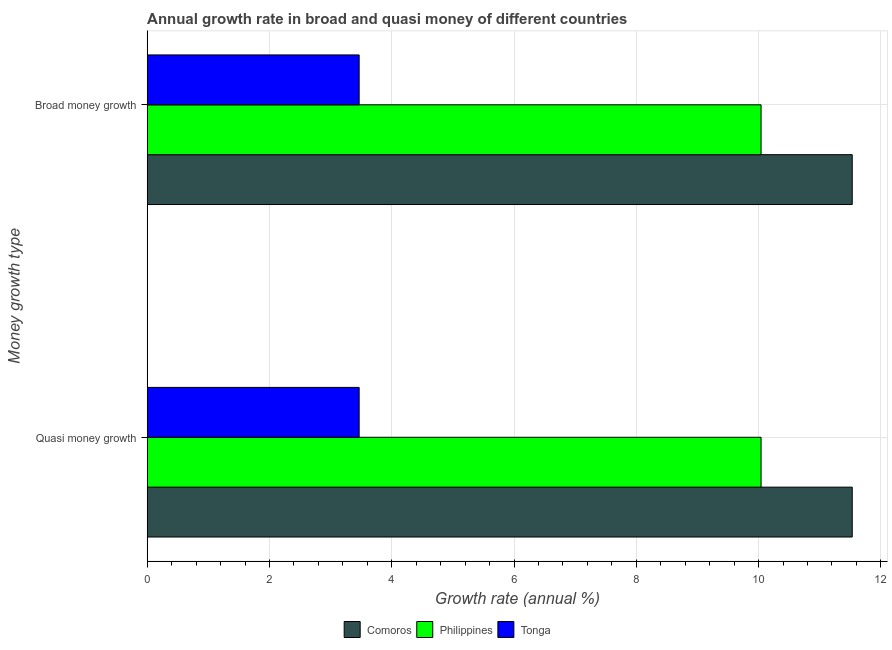How many different coloured bars are there?
Your answer should be compact. 3. Are the number of bars on each tick of the Y-axis equal?
Your response must be concise. Yes. How many bars are there on the 1st tick from the top?
Keep it short and to the point. 3. What is the label of the 2nd group of bars from the top?
Keep it short and to the point. Quasi money growth. What is the annual growth rate in broad money in Comoros?
Provide a short and direct response. 11.53. Across all countries, what is the maximum annual growth rate in broad money?
Your response must be concise. 11.53. Across all countries, what is the minimum annual growth rate in broad money?
Make the answer very short. 3.47. In which country was the annual growth rate in quasi money maximum?
Give a very brief answer. Comoros. In which country was the annual growth rate in quasi money minimum?
Your answer should be very brief. Tonga. What is the total annual growth rate in quasi money in the graph?
Offer a very short reply. 25.04. What is the difference between the annual growth rate in quasi money in Tonga and that in Comoros?
Your answer should be very brief. -8.06. What is the difference between the annual growth rate in broad money in Philippines and the annual growth rate in quasi money in Comoros?
Make the answer very short. -1.49. What is the average annual growth rate in quasi money per country?
Make the answer very short. 8.35. What is the ratio of the annual growth rate in broad money in Comoros to that in Tonga?
Your answer should be compact. 3.33. What does the 3rd bar from the top in Broad money growth represents?
Your response must be concise. Comoros. What does the 1st bar from the bottom in Quasi money growth represents?
Give a very brief answer. Comoros. Are all the bars in the graph horizontal?
Keep it short and to the point. Yes. How many countries are there in the graph?
Provide a short and direct response. 3. What is the difference between two consecutive major ticks on the X-axis?
Offer a very short reply. 2. Are the values on the major ticks of X-axis written in scientific E-notation?
Provide a short and direct response. No. Where does the legend appear in the graph?
Provide a short and direct response. Bottom center. How many legend labels are there?
Your answer should be compact. 3. How are the legend labels stacked?
Offer a very short reply. Horizontal. What is the title of the graph?
Offer a terse response. Annual growth rate in broad and quasi money of different countries. Does "St. Vincent and the Grenadines" appear as one of the legend labels in the graph?
Make the answer very short. No. What is the label or title of the X-axis?
Offer a terse response. Growth rate (annual %). What is the label or title of the Y-axis?
Provide a short and direct response. Money growth type. What is the Growth rate (annual %) of Comoros in Quasi money growth?
Provide a short and direct response. 11.53. What is the Growth rate (annual %) in Philippines in Quasi money growth?
Your answer should be compact. 10.04. What is the Growth rate (annual %) of Tonga in Quasi money growth?
Your response must be concise. 3.47. What is the Growth rate (annual %) of Comoros in Broad money growth?
Make the answer very short. 11.53. What is the Growth rate (annual %) in Philippines in Broad money growth?
Offer a terse response. 10.04. What is the Growth rate (annual %) of Tonga in Broad money growth?
Keep it short and to the point. 3.47. Across all Money growth type, what is the maximum Growth rate (annual %) of Comoros?
Offer a very short reply. 11.53. Across all Money growth type, what is the maximum Growth rate (annual %) of Philippines?
Offer a very short reply. 10.04. Across all Money growth type, what is the maximum Growth rate (annual %) of Tonga?
Keep it short and to the point. 3.47. Across all Money growth type, what is the minimum Growth rate (annual %) in Comoros?
Offer a terse response. 11.53. Across all Money growth type, what is the minimum Growth rate (annual %) in Philippines?
Offer a terse response. 10.04. Across all Money growth type, what is the minimum Growth rate (annual %) of Tonga?
Offer a very short reply. 3.47. What is the total Growth rate (annual %) of Comoros in the graph?
Provide a short and direct response. 23.06. What is the total Growth rate (annual %) in Philippines in the graph?
Offer a terse response. 20.08. What is the total Growth rate (annual %) of Tonga in the graph?
Make the answer very short. 6.93. What is the difference between the Growth rate (annual %) in Comoros in Quasi money growth and that in Broad money growth?
Keep it short and to the point. 0. What is the difference between the Growth rate (annual %) in Philippines in Quasi money growth and that in Broad money growth?
Ensure brevity in your answer.  0. What is the difference between the Growth rate (annual %) in Tonga in Quasi money growth and that in Broad money growth?
Provide a succinct answer. 0. What is the difference between the Growth rate (annual %) of Comoros in Quasi money growth and the Growth rate (annual %) of Philippines in Broad money growth?
Give a very brief answer. 1.49. What is the difference between the Growth rate (annual %) of Comoros in Quasi money growth and the Growth rate (annual %) of Tonga in Broad money growth?
Give a very brief answer. 8.06. What is the difference between the Growth rate (annual %) of Philippines in Quasi money growth and the Growth rate (annual %) of Tonga in Broad money growth?
Keep it short and to the point. 6.57. What is the average Growth rate (annual %) of Comoros per Money growth type?
Provide a succinct answer. 11.53. What is the average Growth rate (annual %) in Philippines per Money growth type?
Make the answer very short. 10.04. What is the average Growth rate (annual %) of Tonga per Money growth type?
Provide a succinct answer. 3.47. What is the difference between the Growth rate (annual %) in Comoros and Growth rate (annual %) in Philippines in Quasi money growth?
Make the answer very short. 1.49. What is the difference between the Growth rate (annual %) of Comoros and Growth rate (annual %) of Tonga in Quasi money growth?
Your answer should be very brief. 8.06. What is the difference between the Growth rate (annual %) in Philippines and Growth rate (annual %) in Tonga in Quasi money growth?
Ensure brevity in your answer.  6.57. What is the difference between the Growth rate (annual %) in Comoros and Growth rate (annual %) in Philippines in Broad money growth?
Provide a succinct answer. 1.49. What is the difference between the Growth rate (annual %) in Comoros and Growth rate (annual %) in Tonga in Broad money growth?
Offer a terse response. 8.06. What is the difference between the Growth rate (annual %) of Philippines and Growth rate (annual %) of Tonga in Broad money growth?
Ensure brevity in your answer.  6.57. What is the difference between the highest and the second highest Growth rate (annual %) of Comoros?
Offer a terse response. 0. What is the difference between the highest and the second highest Growth rate (annual %) of Philippines?
Provide a short and direct response. 0. What is the difference between the highest and the lowest Growth rate (annual %) of Comoros?
Your answer should be very brief. 0. What is the difference between the highest and the lowest Growth rate (annual %) in Tonga?
Provide a short and direct response. 0. 